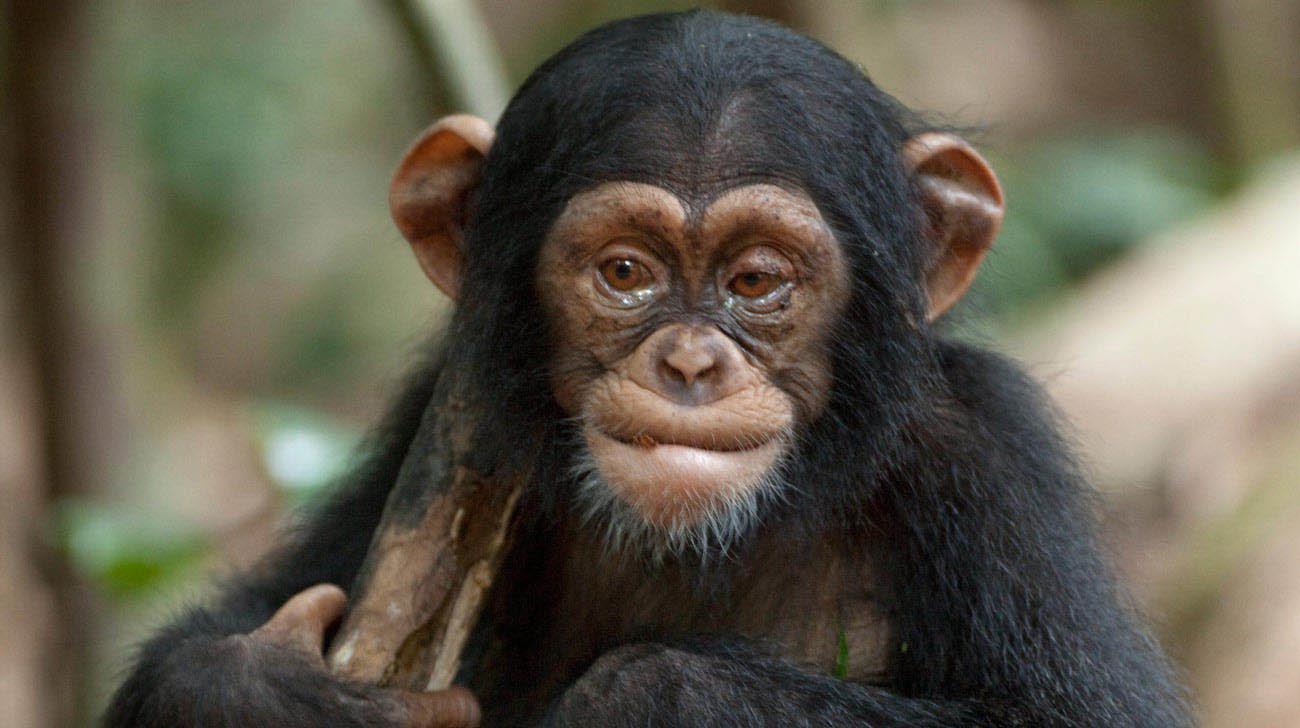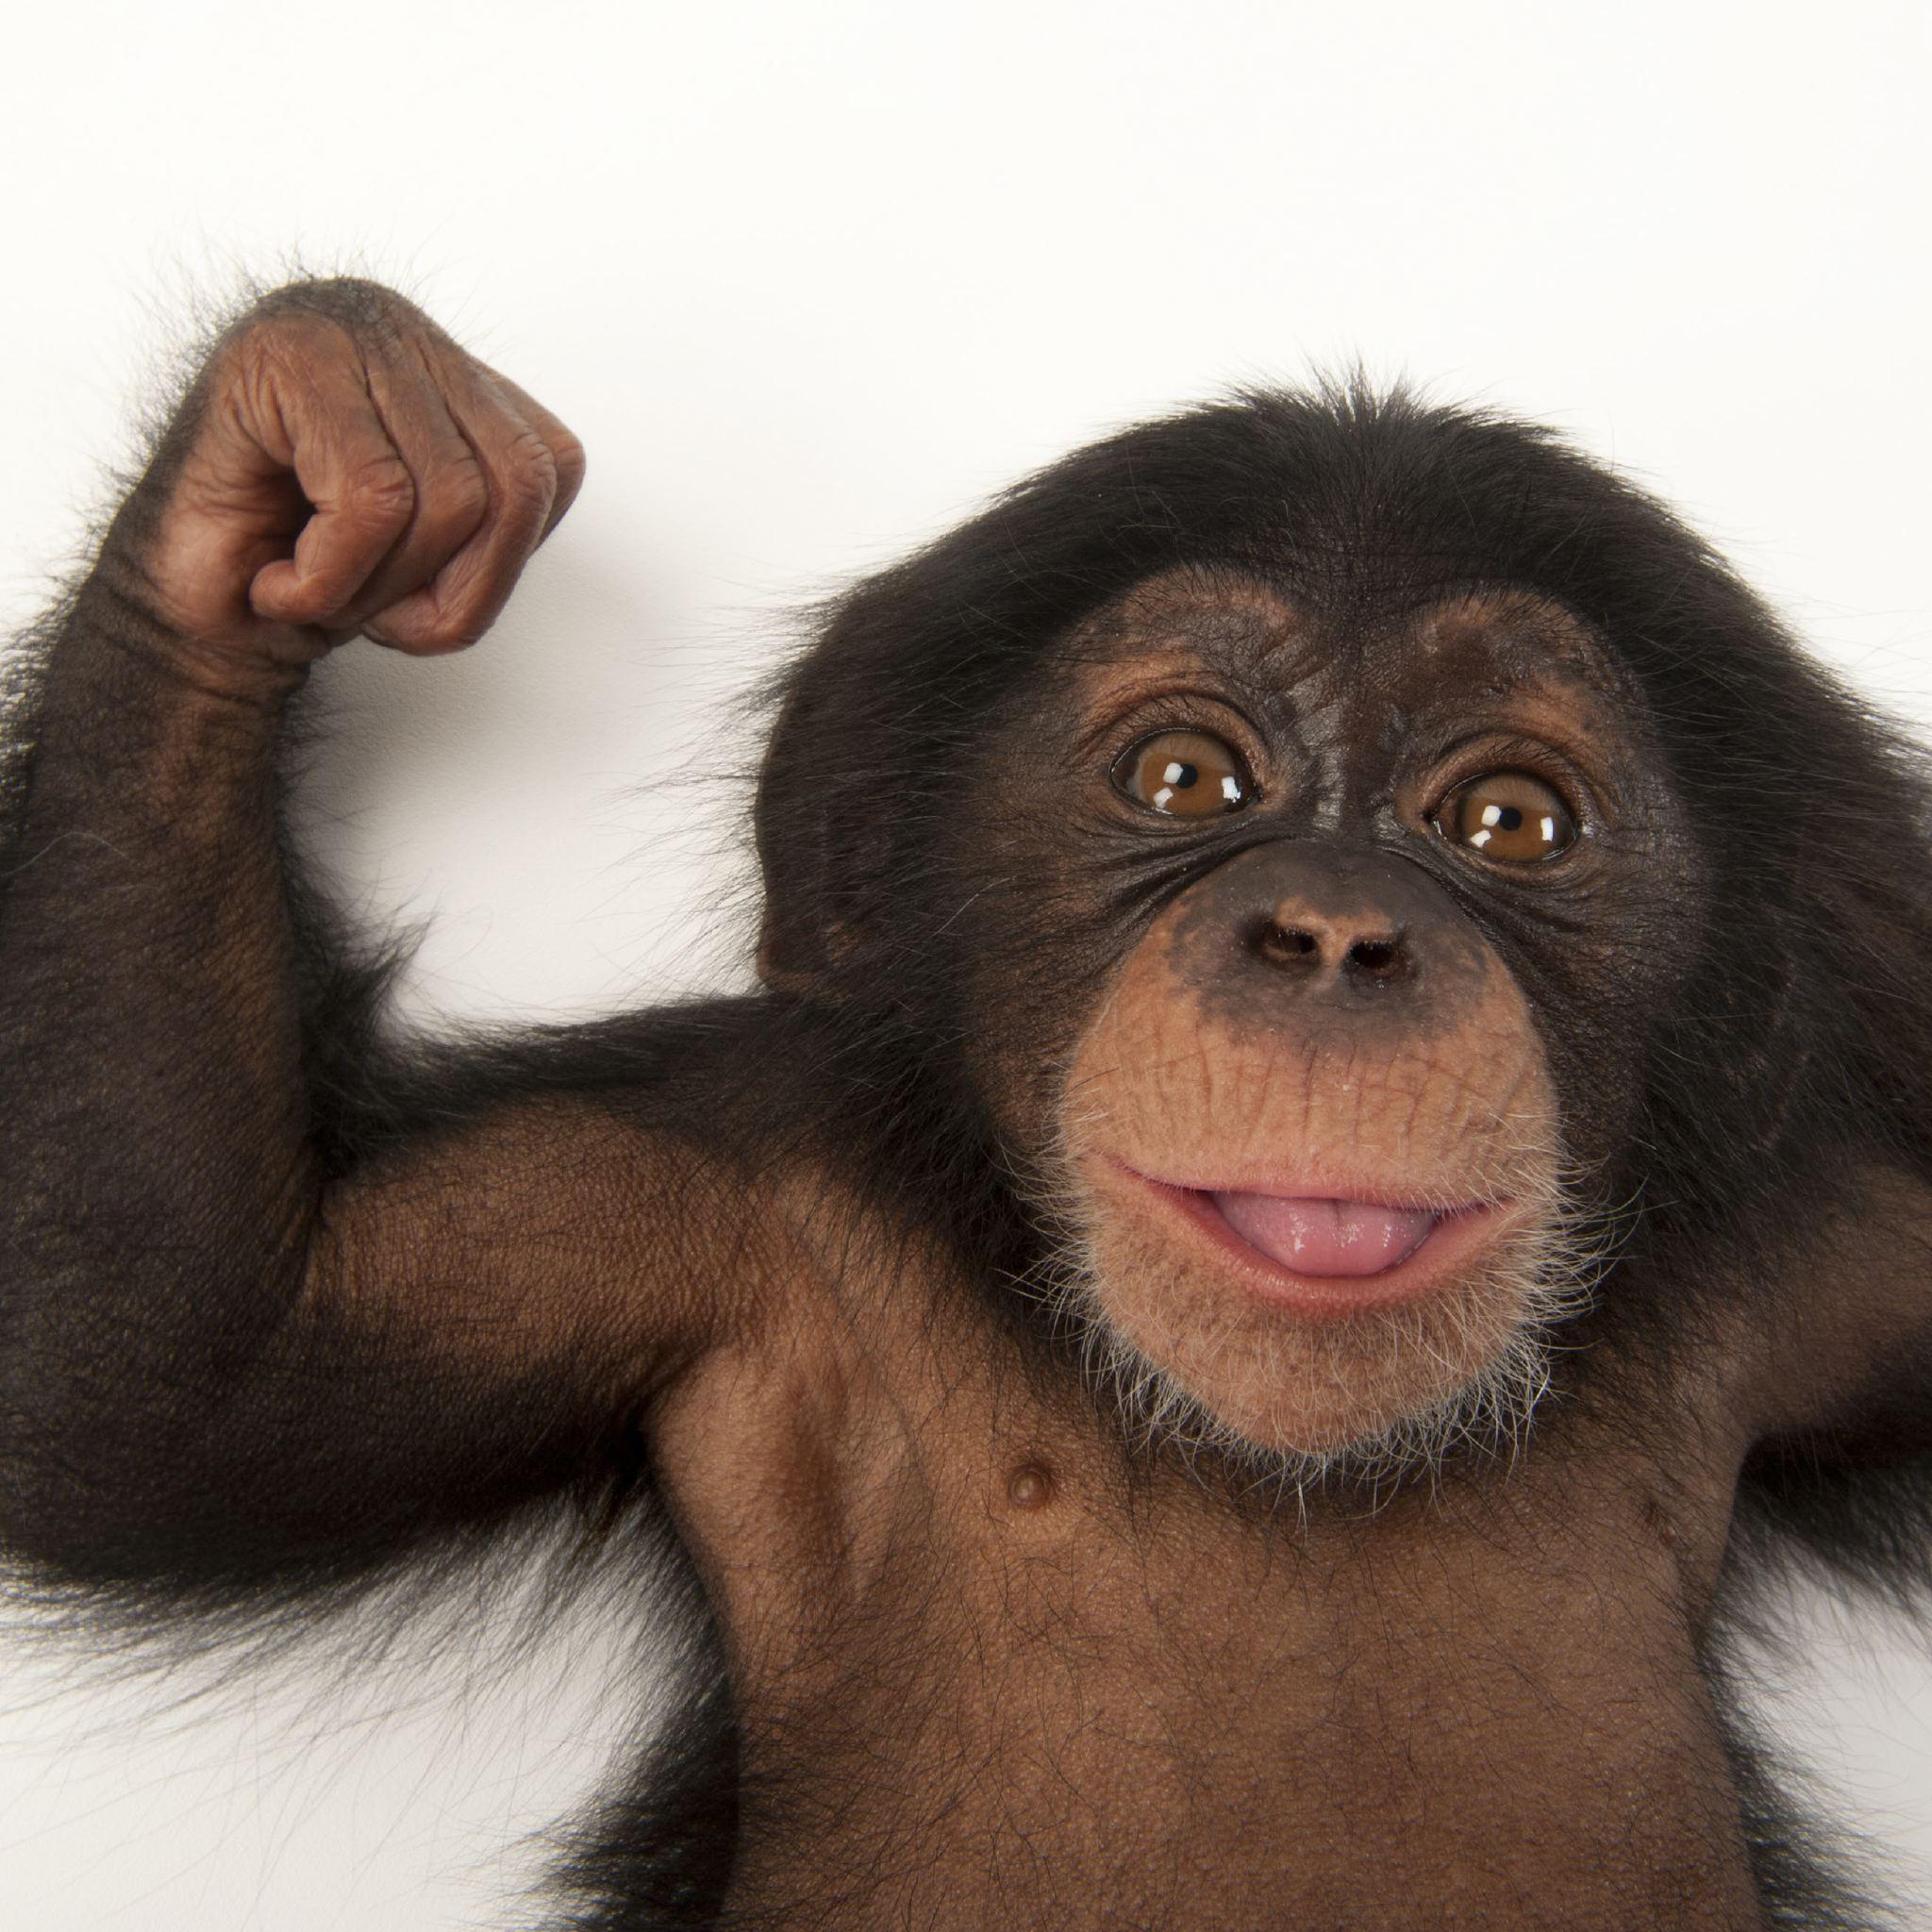The first image is the image on the left, the second image is the image on the right. Analyze the images presented: Is the assertion "There are two apes" valid? Answer yes or no. Yes. 